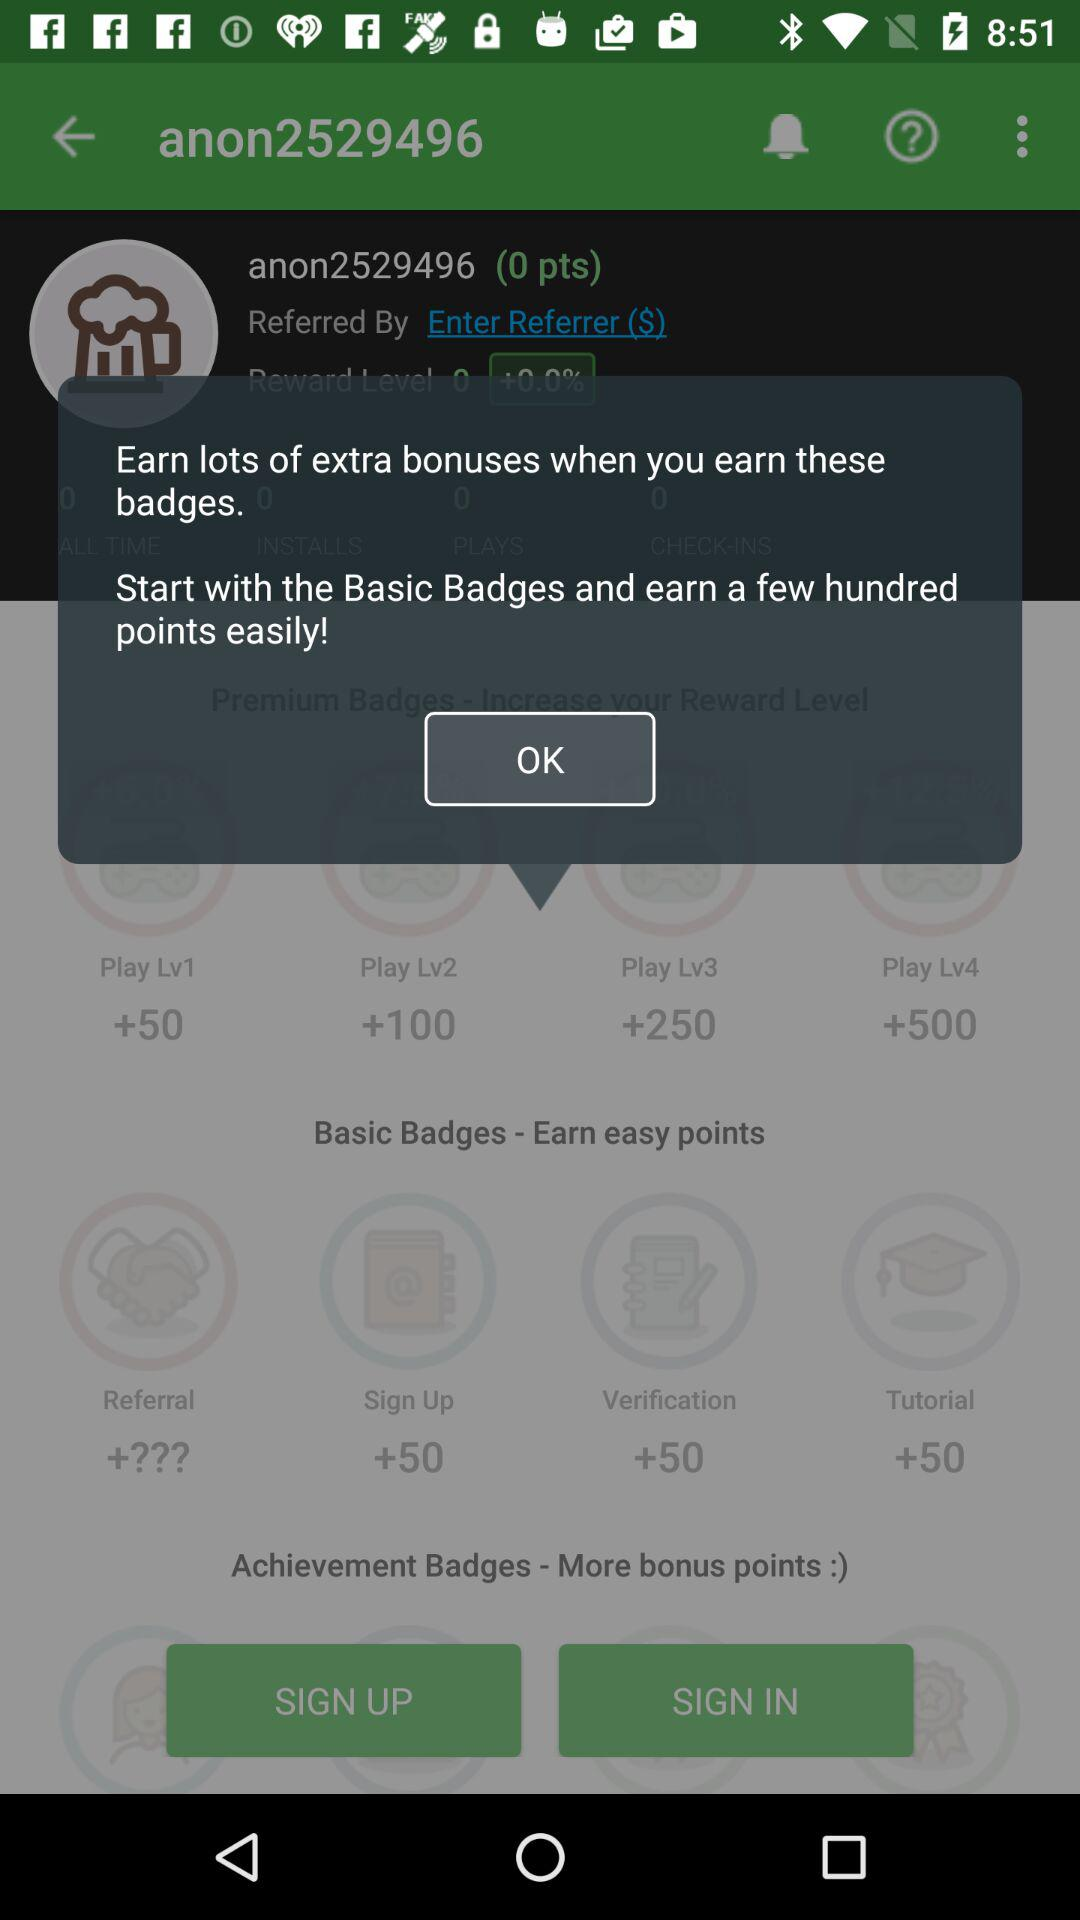How many more points can I earn if I complete all the basic badges?
Answer the question using a single word or phrase. A few hundred 